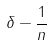<formula> <loc_0><loc_0><loc_500><loc_500>\delta - \frac { 1 } { n }</formula> 